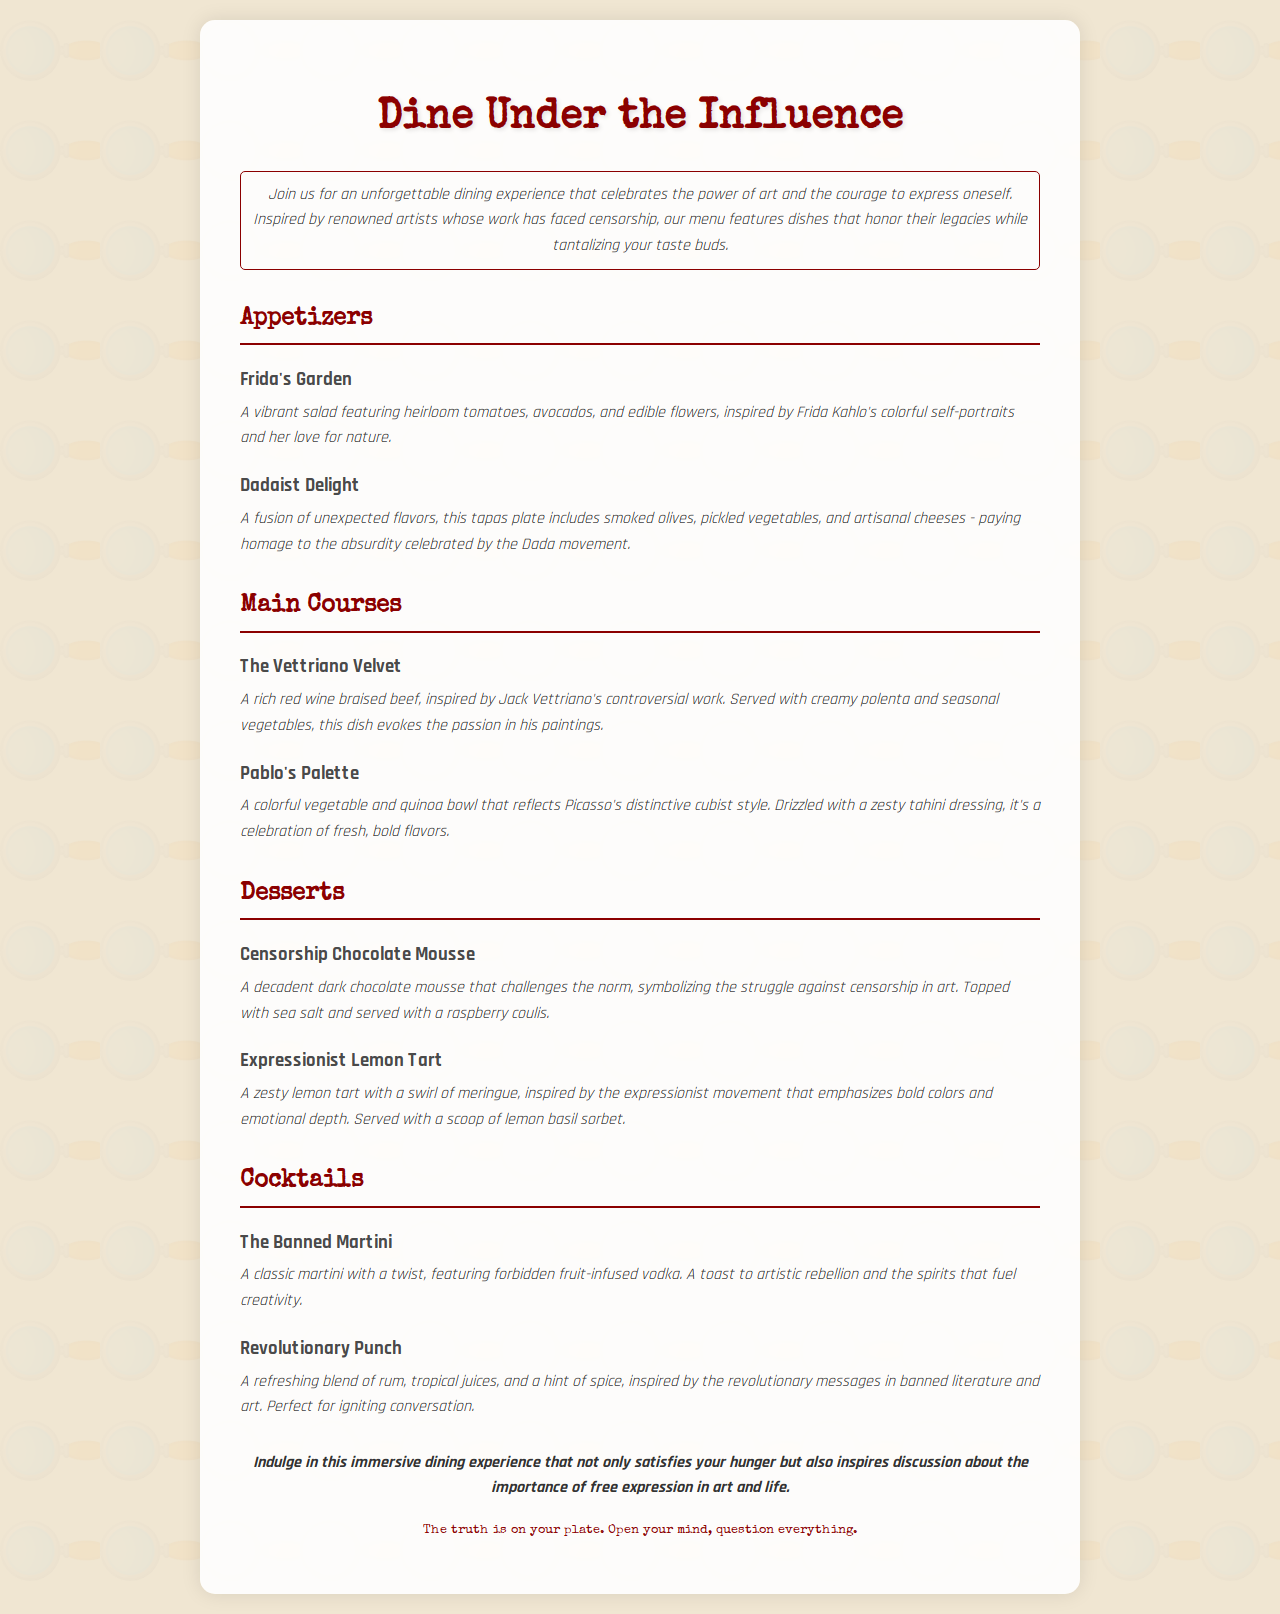What is the name of the themed dining experience? The title of the dining experience is explicitly mentioned at the beginning of the document.
Answer: Dine Under the Influence Who is the artist featured in "Frida's Garden"? The menu item "Frida's Garden" is inspired by the well-known artist Frida Kahlo.
Answer: Frida Kahlo What type of dish is "Censorship Chocolate Mousse"? The description of "Censorship Chocolate Mousse" provides the specific type of dish it is in the dessert category.
Answer: Dessert How many main courses are listed on the menu? By counting the main course items in the menu section, we can determine the total number.
Answer: 2 What ingredient is used in "Pablo's Palette" dressing? The menu item "Pablo's Palette" mentions a specific ingredient in its dressing, which helps to identify it.
Answer: Tahini Which cocktail is infused with forbidden fruit? The menu clearly states the name of the cocktail that includes forbidden fruit-infused vodka.
Answer: The Banned Martini What is the texture of "Expressionist Lemon Tart"? The description clarifies the texture and type of topping associated with "Expressionist Lemon Tart."
Answer: Swirl of meringue What common theme connects the dishes in this menu? The overall theme of the menu can be inferred from the introduction.
Answer: Free expression 